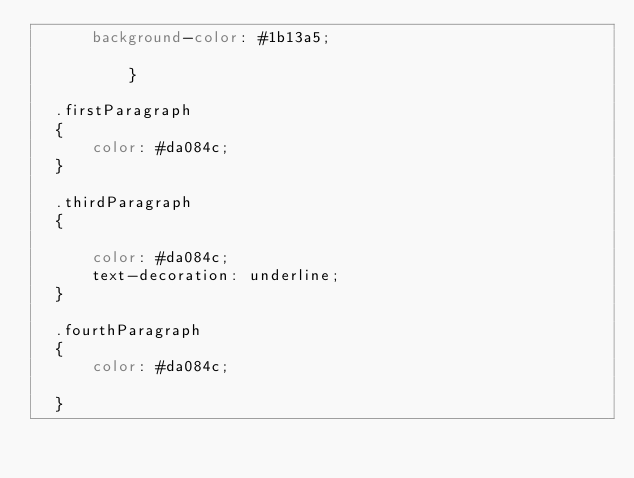Convert code to text. <code><loc_0><loc_0><loc_500><loc_500><_CSS_>      background-color: #1b13a5;
    
          }

  .firstParagraph
  {
      color: #da084c;
  }

  .thirdParagraph
  {

      color: #da084c;
      text-decoration: underline;
  }

  .fourthParagraph
  {
      color: #da084c;

  }

</code> 